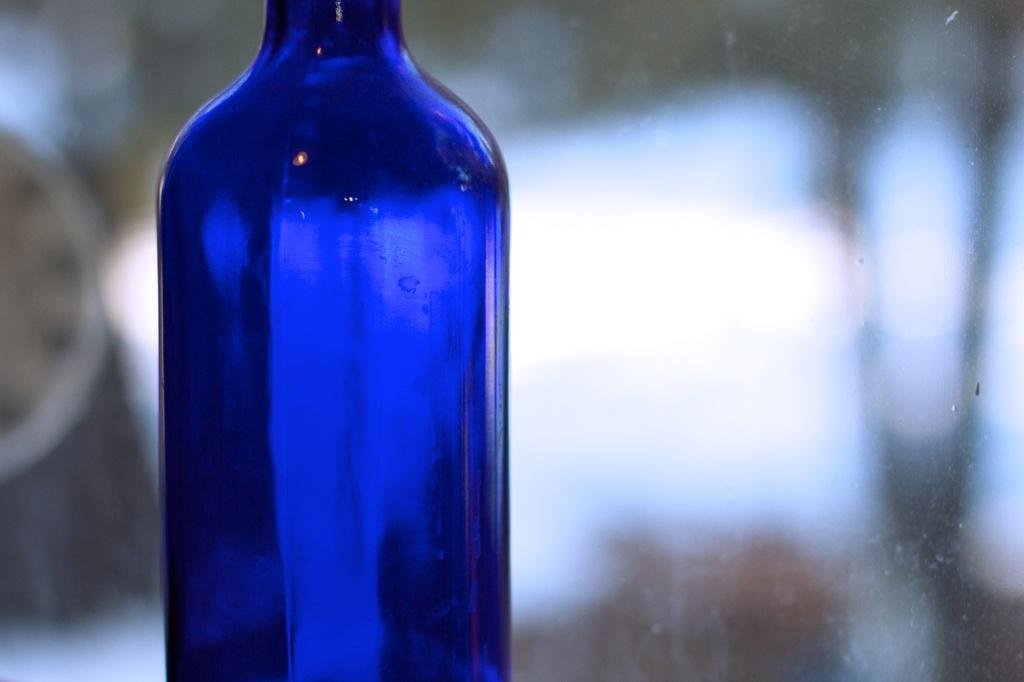What color is the bottle that is visible in the image? There is a blue bottle in the image. Can you describe the background of the image? The background of the image is blurry. How many birds are sitting on the knowledge in the image? There are no birds or knowledge present in the image. 